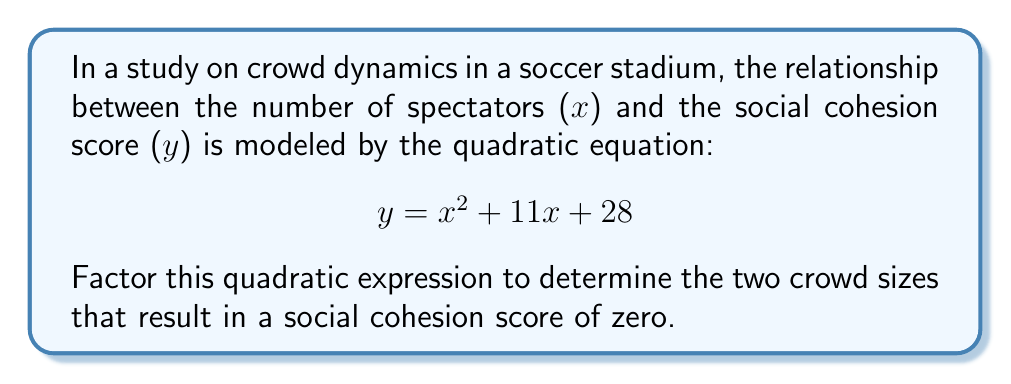Provide a solution to this math problem. To factor this quadratic expression, we'll follow these steps:

1) The quadratic expression is in the form $ax^2 + bx + c$, where:
   $a = 1$, $b = 11$, and $c = 28$

2) We need to find two numbers that multiply to give $ac = 1 * 28 = 28$ and add up to $b = 11$

3) The factors of 28 are: 1, 2, 4, 7, 14, 28
   By inspection, we can see that 4 and 7 add up to 11

4) We can rewrite the middle term using these numbers:
   $$y = x^2 + 11x + 28$$
   $$y = x^2 + 4x + 7x + 28$$

5) Now we can factor by grouping:
   $$y = (x^2 + 4x) + (7x + 28)$$
   $$y = x(x + 4) + 7(x + 4)$$
   $$y = (x + 7)(x + 4)$$

6) The roots of this equation (where y = 0) are when $(x + 7) = 0$ or $(x + 4) = 0$
   So, $x = -7$ or $x = -4$

7) Since x represents the number of spectators, and we can't have negative spectators, we interpret these results as follows:
   The social cohesion score would theoretically be zero when there are 7 or 4 spectators leaving the stadium (hence the negative signs).
Answer: $(x + 7)(x + 4)$ 